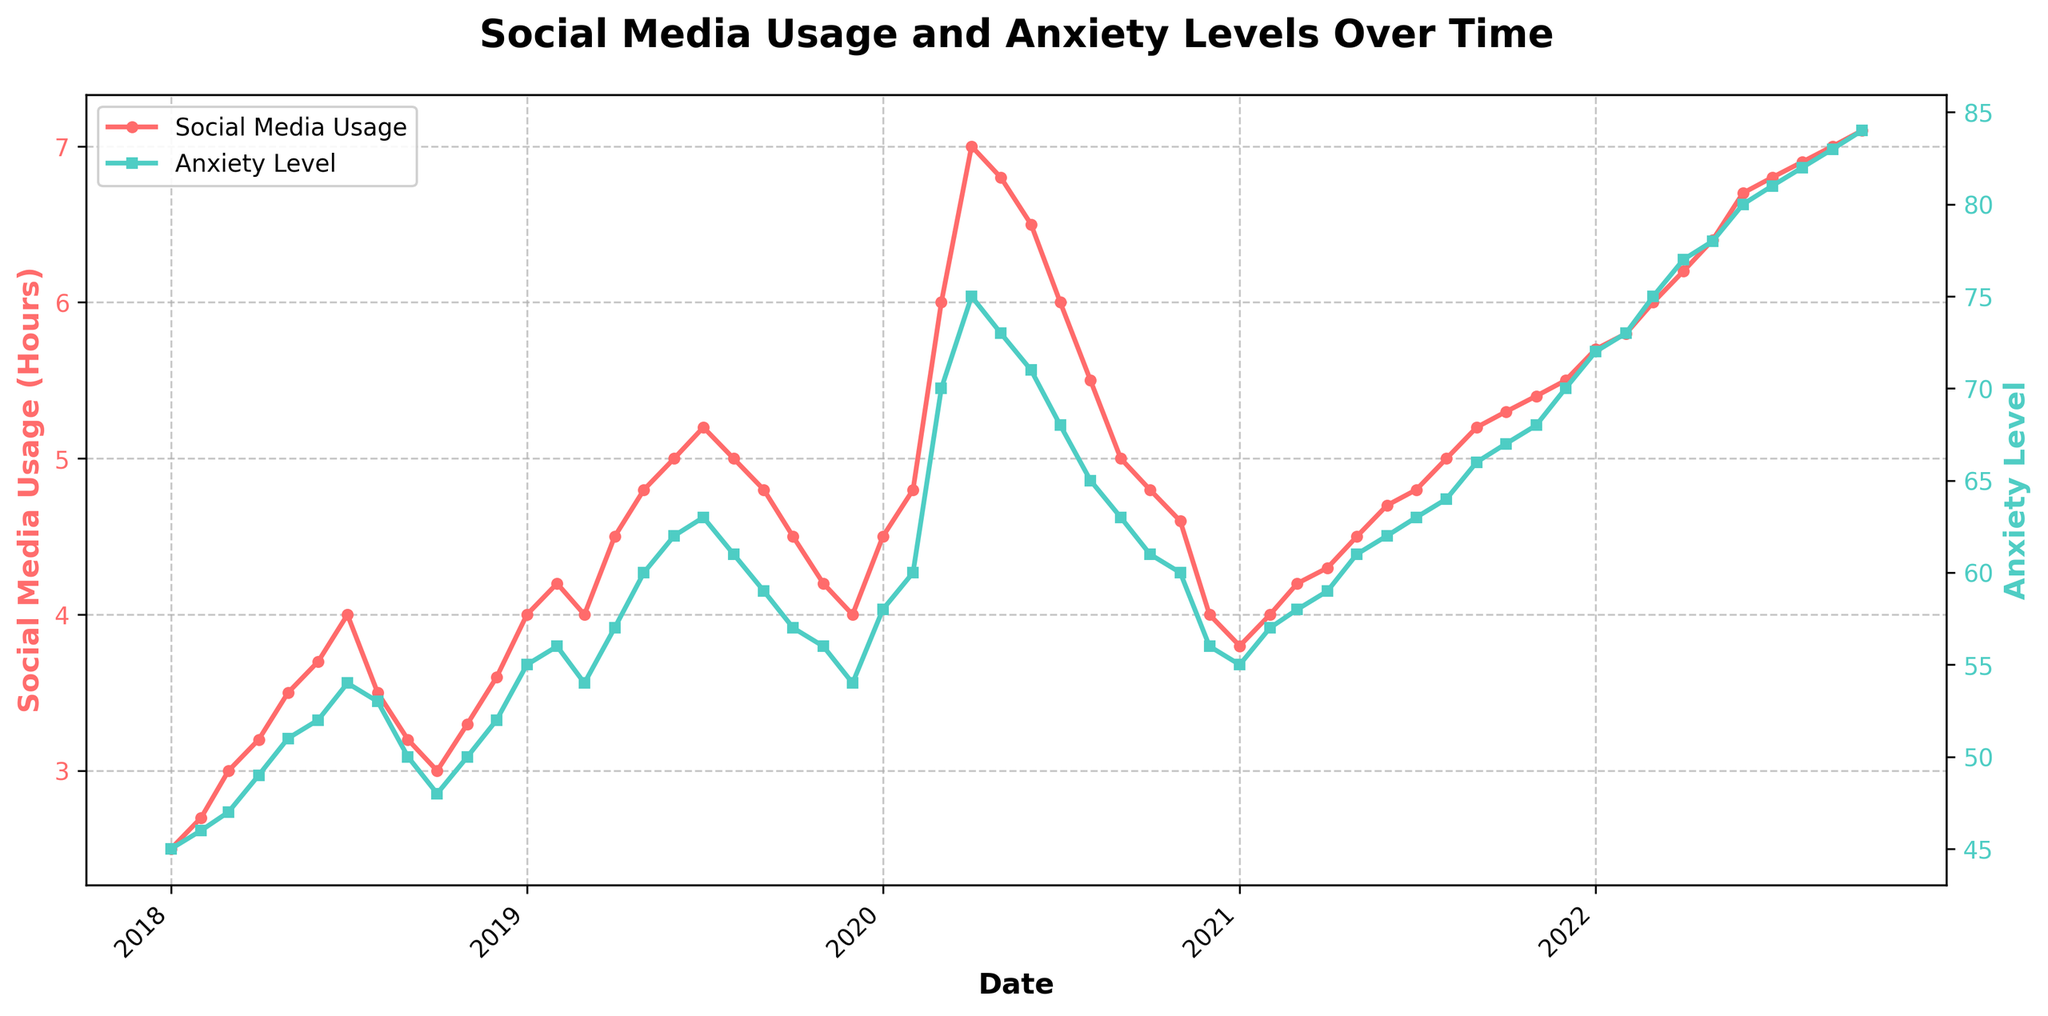What does the title of the figure indicate about the data being shown? The title of the figure is "Social Media Usage and Anxiety Levels Over Time." This indicates that the plot shows the relationship between the duration of social media usage and anxiety levels among teenagers over a certain period.
Answer: It shows the relationship between social media usage and anxiety levels over time What are the two variables plotted on the y-axes, and how are they visually distinguished? The two variables plotted on the y-axes are Social Media Usage (Hours) on the left y-axis and Anxiety Level on the right y-axis. Social Media Usage is visualized using a red line with circular markers, while Anxiety Level is visualized using a teal line with square markers.
Answer: Social Media Usage (red line with circles) and Anxiety Level (teal line with squares) How did the social media usage trend change from January 2018 to October 2022? From January 2018 to October 2022, social media usage generally increased. Starting at around 2.5 hours in January 2018, it grew steadily with minor fluctuations to around 7.1 hours in October 2022.
Answer: It generally increased What is the correlation between social media usage and anxiety levels? Observing the plot, as social media usage increases, anxiety levels also tend to increase. For most of the time periods, higher social media usage corresponds to higher anxiety levels, indicating a positive correlation.
Answer: Positive correlation During which months did the anxiety level peak in 2020, and what were the corresponding social media usage hours? The anxiety level peaked in March and April 2020 at 70 and 75 respectively. The corresponding social media usage hours were 6.0 in March and 7.0 in April.
Answer: March and April; 6.0 and 7.0 hours Compare the social media usage and anxiety levels between January 2019 and December 2020. In January 2019, social media usage was 4.0 hours, and the anxiety level was 55. In December 2020, social media usage was 4.0 hours, and the anxiety level was 56. Social media usage returned to the starting value, but anxiety was slightly higher by 1 point.
Answer: Usage: 4.0 hours same; Anxiety: 55 to 56 What was the rate of increase in social media usage hours from January 2020 to April 2020? In January 2020, social media usage was 4.5 hours, and in April 2020, it was 7.0 hours. The increase was 7.0 - 4.5 = 2.5 hours over 3 months, giving an approximate rate of 0.83 hours per month (2.5/3).
Answer: 0.83 hours per month What changes occurred in the anxiety levels from June 2020 to January 2021? In June 2020, the anxiety level was 71. By January 2021, the anxiety level had decreased to 55. This means that over this period, the anxiety level dropped by 16 points (71 - 55).
Answer: Decreased by 16 points During what period did anxiety levels consistently increase without any drop, and what was the social media usage trend during this time? From January 2022 to October 2022, anxiety levels consistently increased from 72 to 84. During the same time period, social media usage also increased consistently from 5.7 hours to 7.1 hours.
Answer: January 2022 to October 2022; both levels increased What insights can be drawn about the general relationship between social media usage and anxiety levels throughout the given period? The relationship between social media usage and anxiety levels appears to be directly proportional. As social media usage increases, anxiety levels typically increase, suggesting a linkage where higher social media usage may contribute to higher anxiety levels among teenagers.
Answer: Direct proportional relationship 